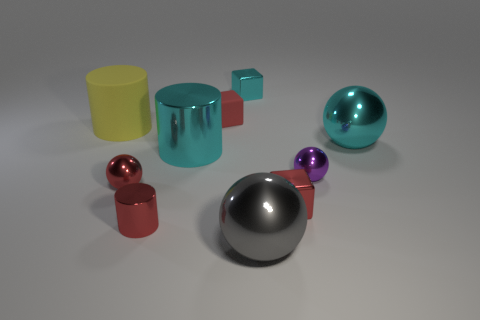What is the material of the small red cube that is in front of the red block that is behind the cube that is right of the cyan cube?
Offer a terse response. Metal. Are there an equal number of tiny things that are in front of the big rubber thing and shiny cylinders?
Offer a terse response. No. How many things are either purple matte cubes or tiny metal blocks?
Your answer should be very brief. 2. There is a tiny purple object that is made of the same material as the gray object; what is its shape?
Your response must be concise. Sphere. How big is the cyan thing that is to the right of the red shiny thing to the right of the tiny cyan cube?
Your answer should be compact. Large. How many tiny things are either spheres or red cylinders?
Provide a succinct answer. 3. How many other objects are the same color as the rubber block?
Make the answer very short. 3. Do the cube that is in front of the tiny purple ball and the metallic cube behind the rubber cube have the same size?
Your response must be concise. Yes. Is the material of the yellow object the same as the small red cube on the left side of the big gray metallic object?
Your answer should be compact. Yes. Is the number of metallic cubes on the right side of the large yellow rubber cylinder greater than the number of blocks in front of the small red rubber object?
Keep it short and to the point. Yes. 